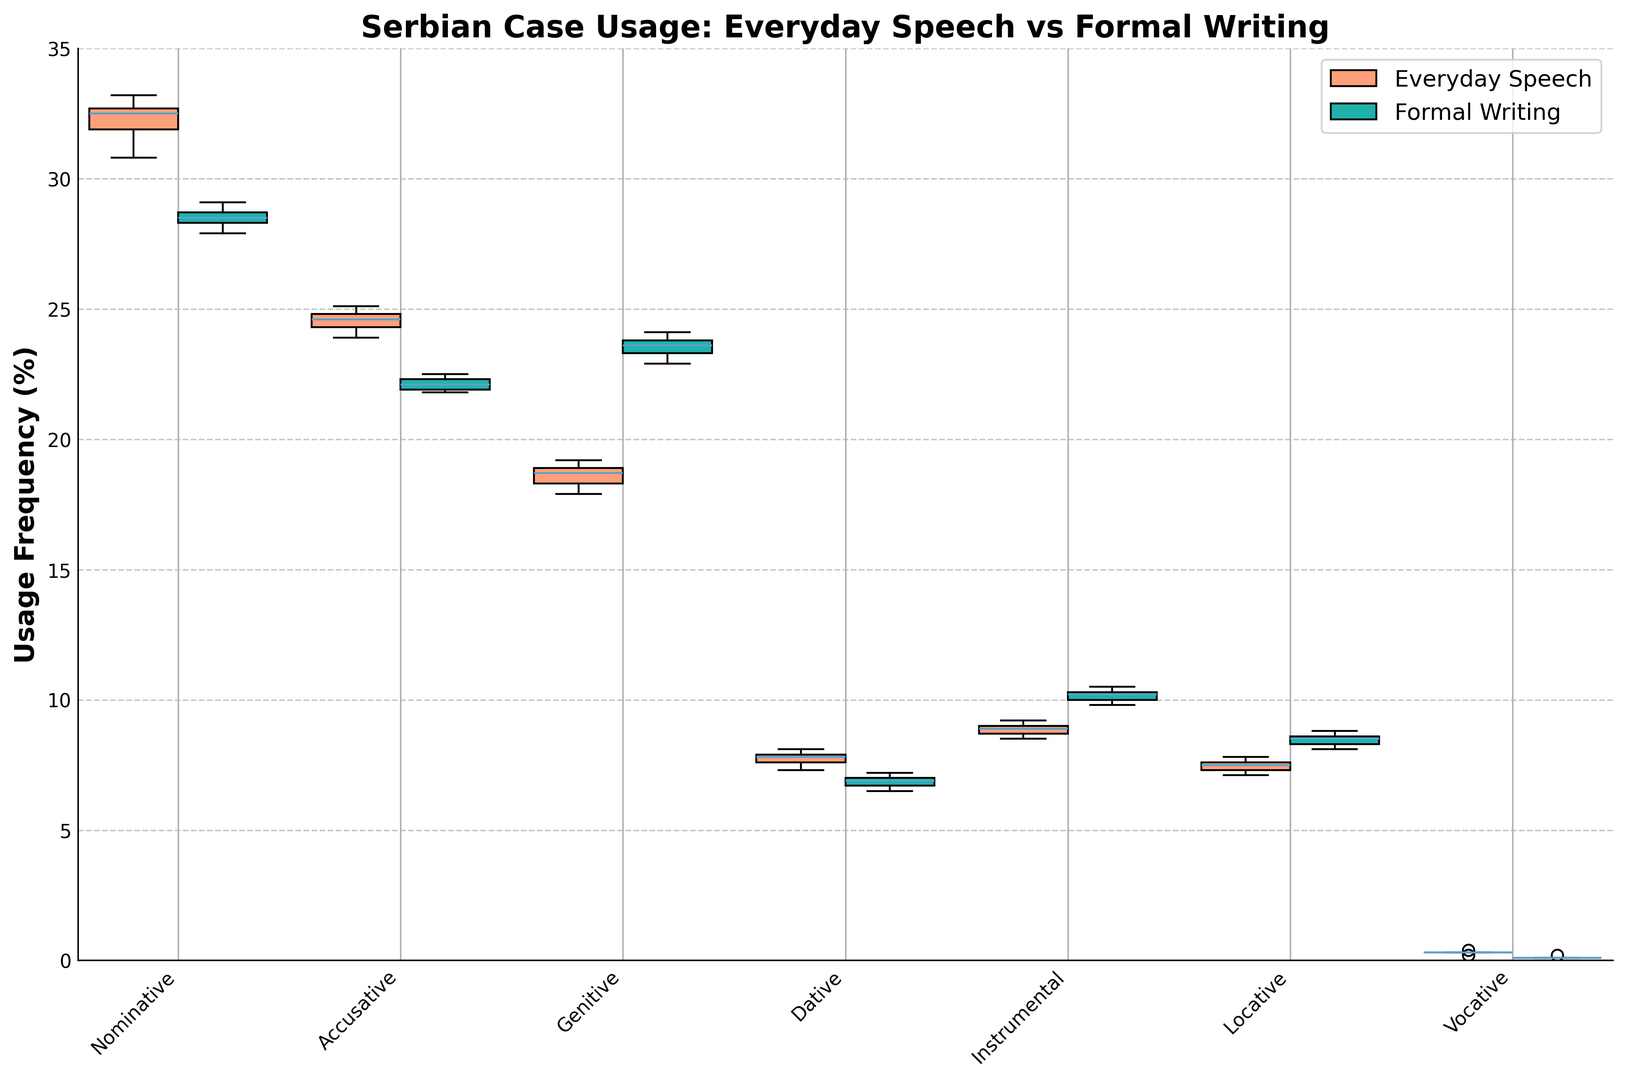Which Serbian case has the highest median usage frequency in everyday speech? For everyday speech, look at the median lines within each box. The nominative case has the highest median usage frequency in everyday speech.
Answer: Nominative Which case usage shows the greatest difference between everyday speech and formal writing? To determine the greatest difference, compare the boxes for each case by looking at how far they are apart. The genitive case shows the greatest difference, with a much higher median in formal writing compared to everyday speech.
Answer: Genitive Which case is used least frequently in both everyday speech and formal writing? Look for the lowest boxes in both everyday speech and formal writing categories. The vocative case has the lowest usage frequency in both contexts.
Answer: Vocative Compare the ranges of the nominative case usage in everyday speech and formal writing. The range is the difference between the maximum and minimum values in the box plot. In everyday speech, the nominative case has a range from about 30.8% to 33.2%. In formal writing, it ranges from about 27.9% to 29.1%.
Answer: Everyday: ~30.8%-33.2%, Formal: ~27.9%-29.1% Which case has the most similar median usage frequency between everyday speech and formal writing? Identify the cases where the median lines in the boxes are closest together. The dative and locative cases show the most similar median usage frequencies in both everyday speech and formal writing.
Answer: Dative and Locative How does the usage of the instrumental case compare visualy between everyday speech and formal writing? Compare the heights of the boxes for the instrumental case. The instrumental case is used more frequently in formal writing, with higher median and upper quartile values compared to everyday speech.
Answer: More frequent in Formal Writing What is the case that shows an increase in usage frequency from everyday speech to formal writing? Compare the median usage frequencies. The genitive, instrumental, and locative cases show an increase in usage frequency from everyday speech to formal writing.
Answer: Genitive, Instrumental, Locative 